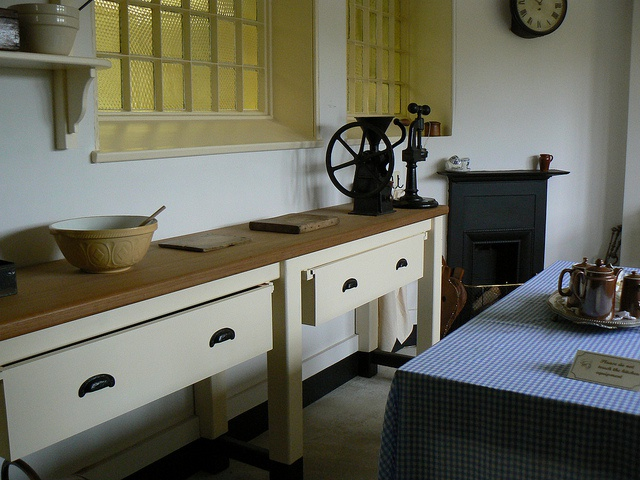Describe the objects in this image and their specific colors. I can see dining table in gray, black, and darkgray tones, bowl in gray, black, olive, and darkgray tones, bowl in gray, black, and darkgreen tones, clock in gray, black, and darkgreen tones, and bowl in gray, black, and darkgreen tones in this image. 